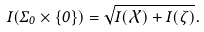<formula> <loc_0><loc_0><loc_500><loc_500>I ( \Sigma _ { 0 } \times \{ 0 \} ) = \sqrt { I ( \mathcal { X } ) + I ( \zeta ) } .</formula> 